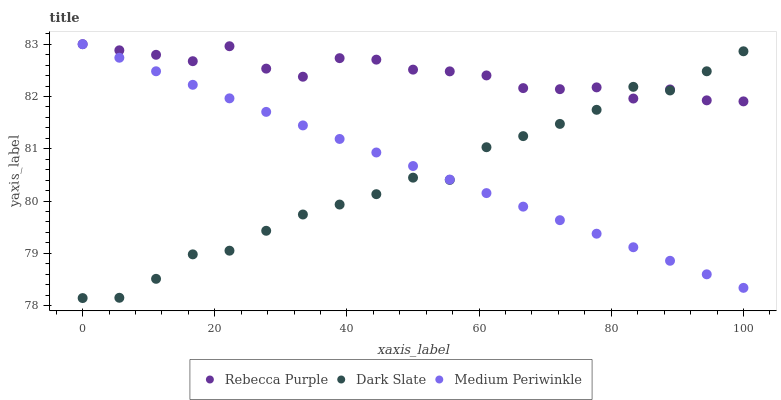Does Dark Slate have the minimum area under the curve?
Answer yes or no. Yes. Does Rebecca Purple have the maximum area under the curve?
Answer yes or no. Yes. Does Medium Periwinkle have the minimum area under the curve?
Answer yes or no. No. Does Medium Periwinkle have the maximum area under the curve?
Answer yes or no. No. Is Medium Periwinkle the smoothest?
Answer yes or no. Yes. Is Rebecca Purple the roughest?
Answer yes or no. Yes. Is Rebecca Purple the smoothest?
Answer yes or no. No. Is Medium Periwinkle the roughest?
Answer yes or no. No. Does Dark Slate have the lowest value?
Answer yes or no. Yes. Does Medium Periwinkle have the lowest value?
Answer yes or no. No. Does Rebecca Purple have the highest value?
Answer yes or no. Yes. Does Rebecca Purple intersect Dark Slate?
Answer yes or no. Yes. Is Rebecca Purple less than Dark Slate?
Answer yes or no. No. Is Rebecca Purple greater than Dark Slate?
Answer yes or no. No. 